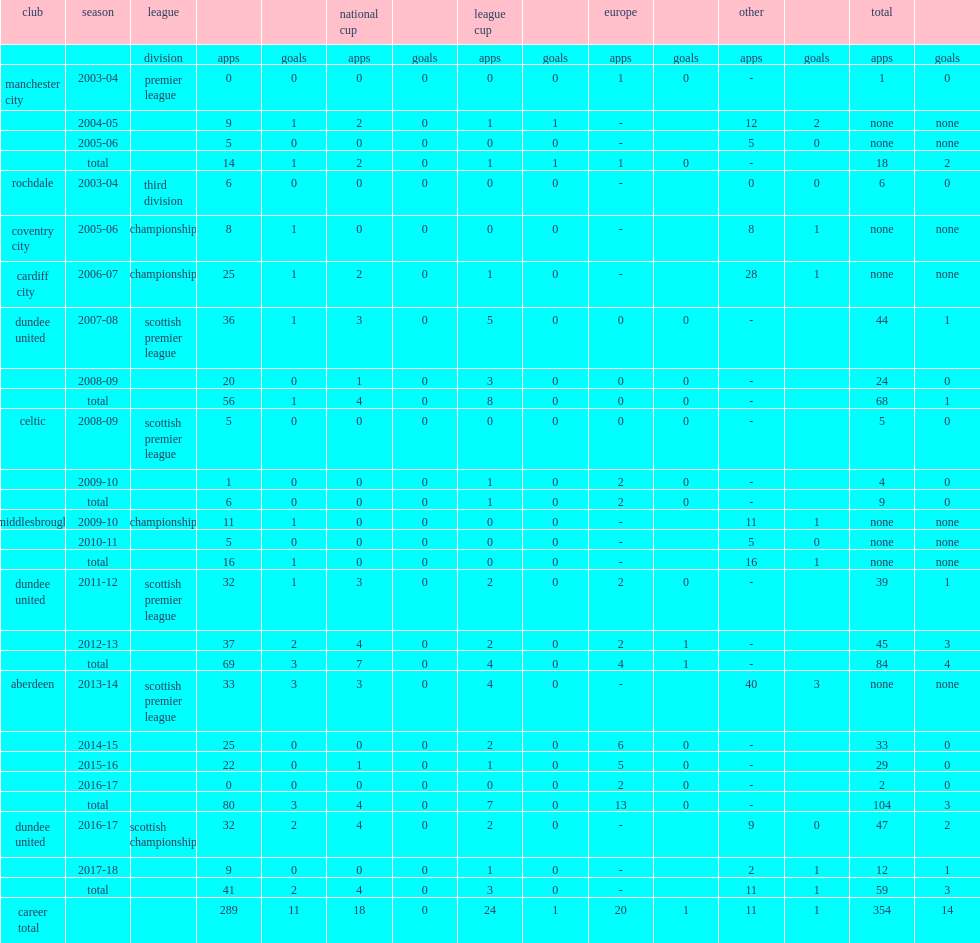How many goals did flood score in the scottish league with club aberdeen in the first season? 3.0. 